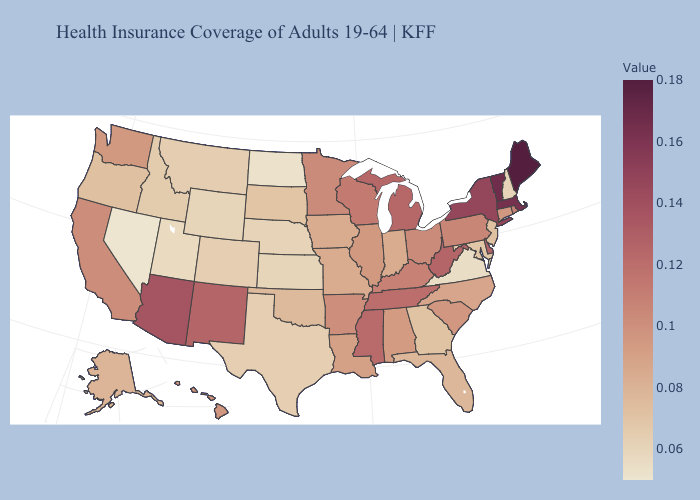Does Oregon have a lower value than Virginia?
Answer briefly. No. Among the states that border Mississippi , which have the highest value?
Quick response, please. Tennessee. Which states have the lowest value in the USA?
Short answer required. Nevada. Which states have the lowest value in the USA?
Answer briefly. Nevada. Among the states that border California , which have the lowest value?
Quick response, please. Nevada. Does Nevada have the lowest value in the USA?
Answer briefly. Yes. 